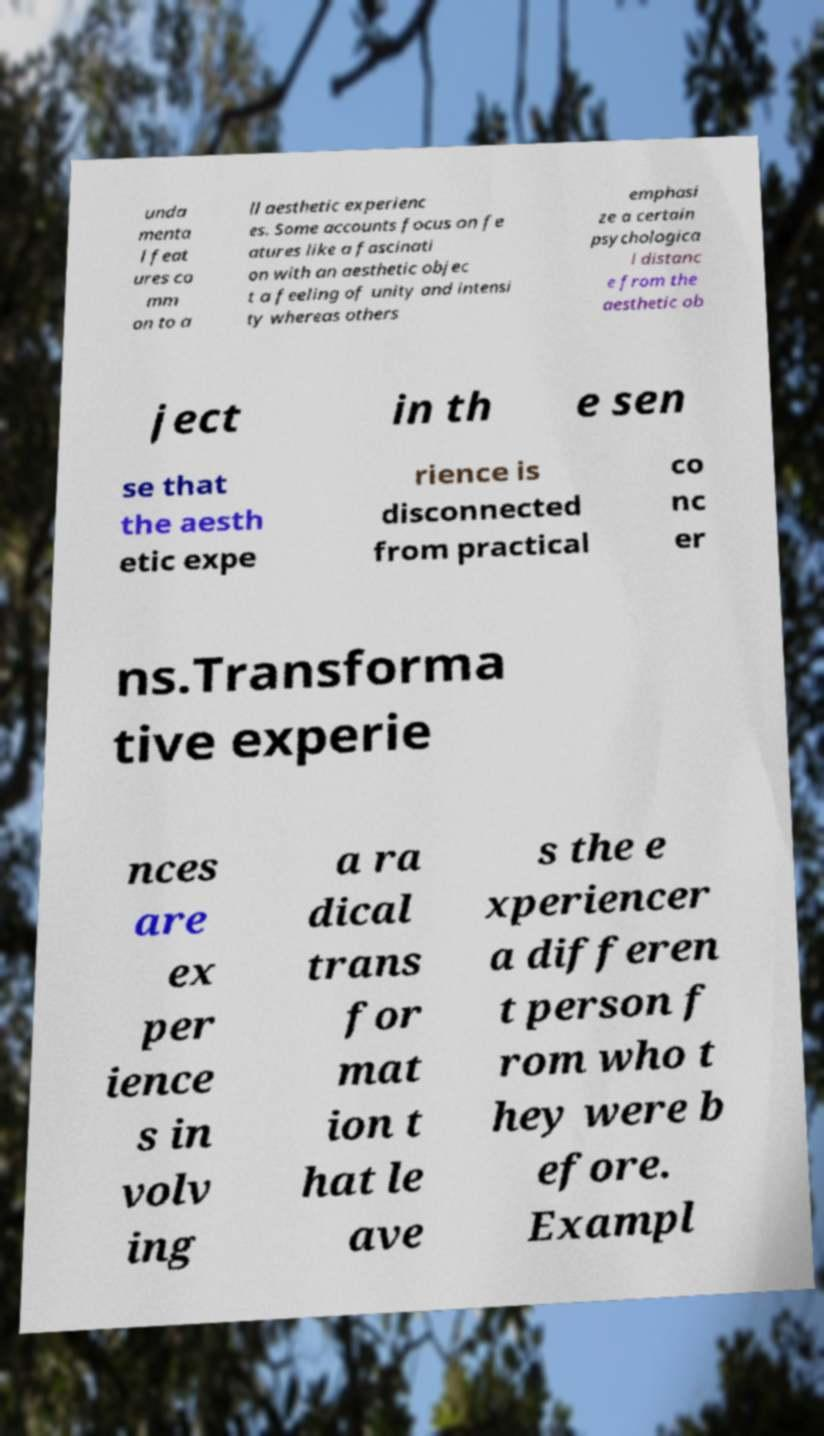I need the written content from this picture converted into text. Can you do that? unda menta l feat ures co mm on to a ll aesthetic experienc es. Some accounts focus on fe atures like a fascinati on with an aesthetic objec t a feeling of unity and intensi ty whereas others emphasi ze a certain psychologica l distanc e from the aesthetic ob ject in th e sen se that the aesth etic expe rience is disconnected from practical co nc er ns.Transforma tive experie nces are ex per ience s in volv ing a ra dical trans for mat ion t hat le ave s the e xperiencer a differen t person f rom who t hey were b efore. Exampl 